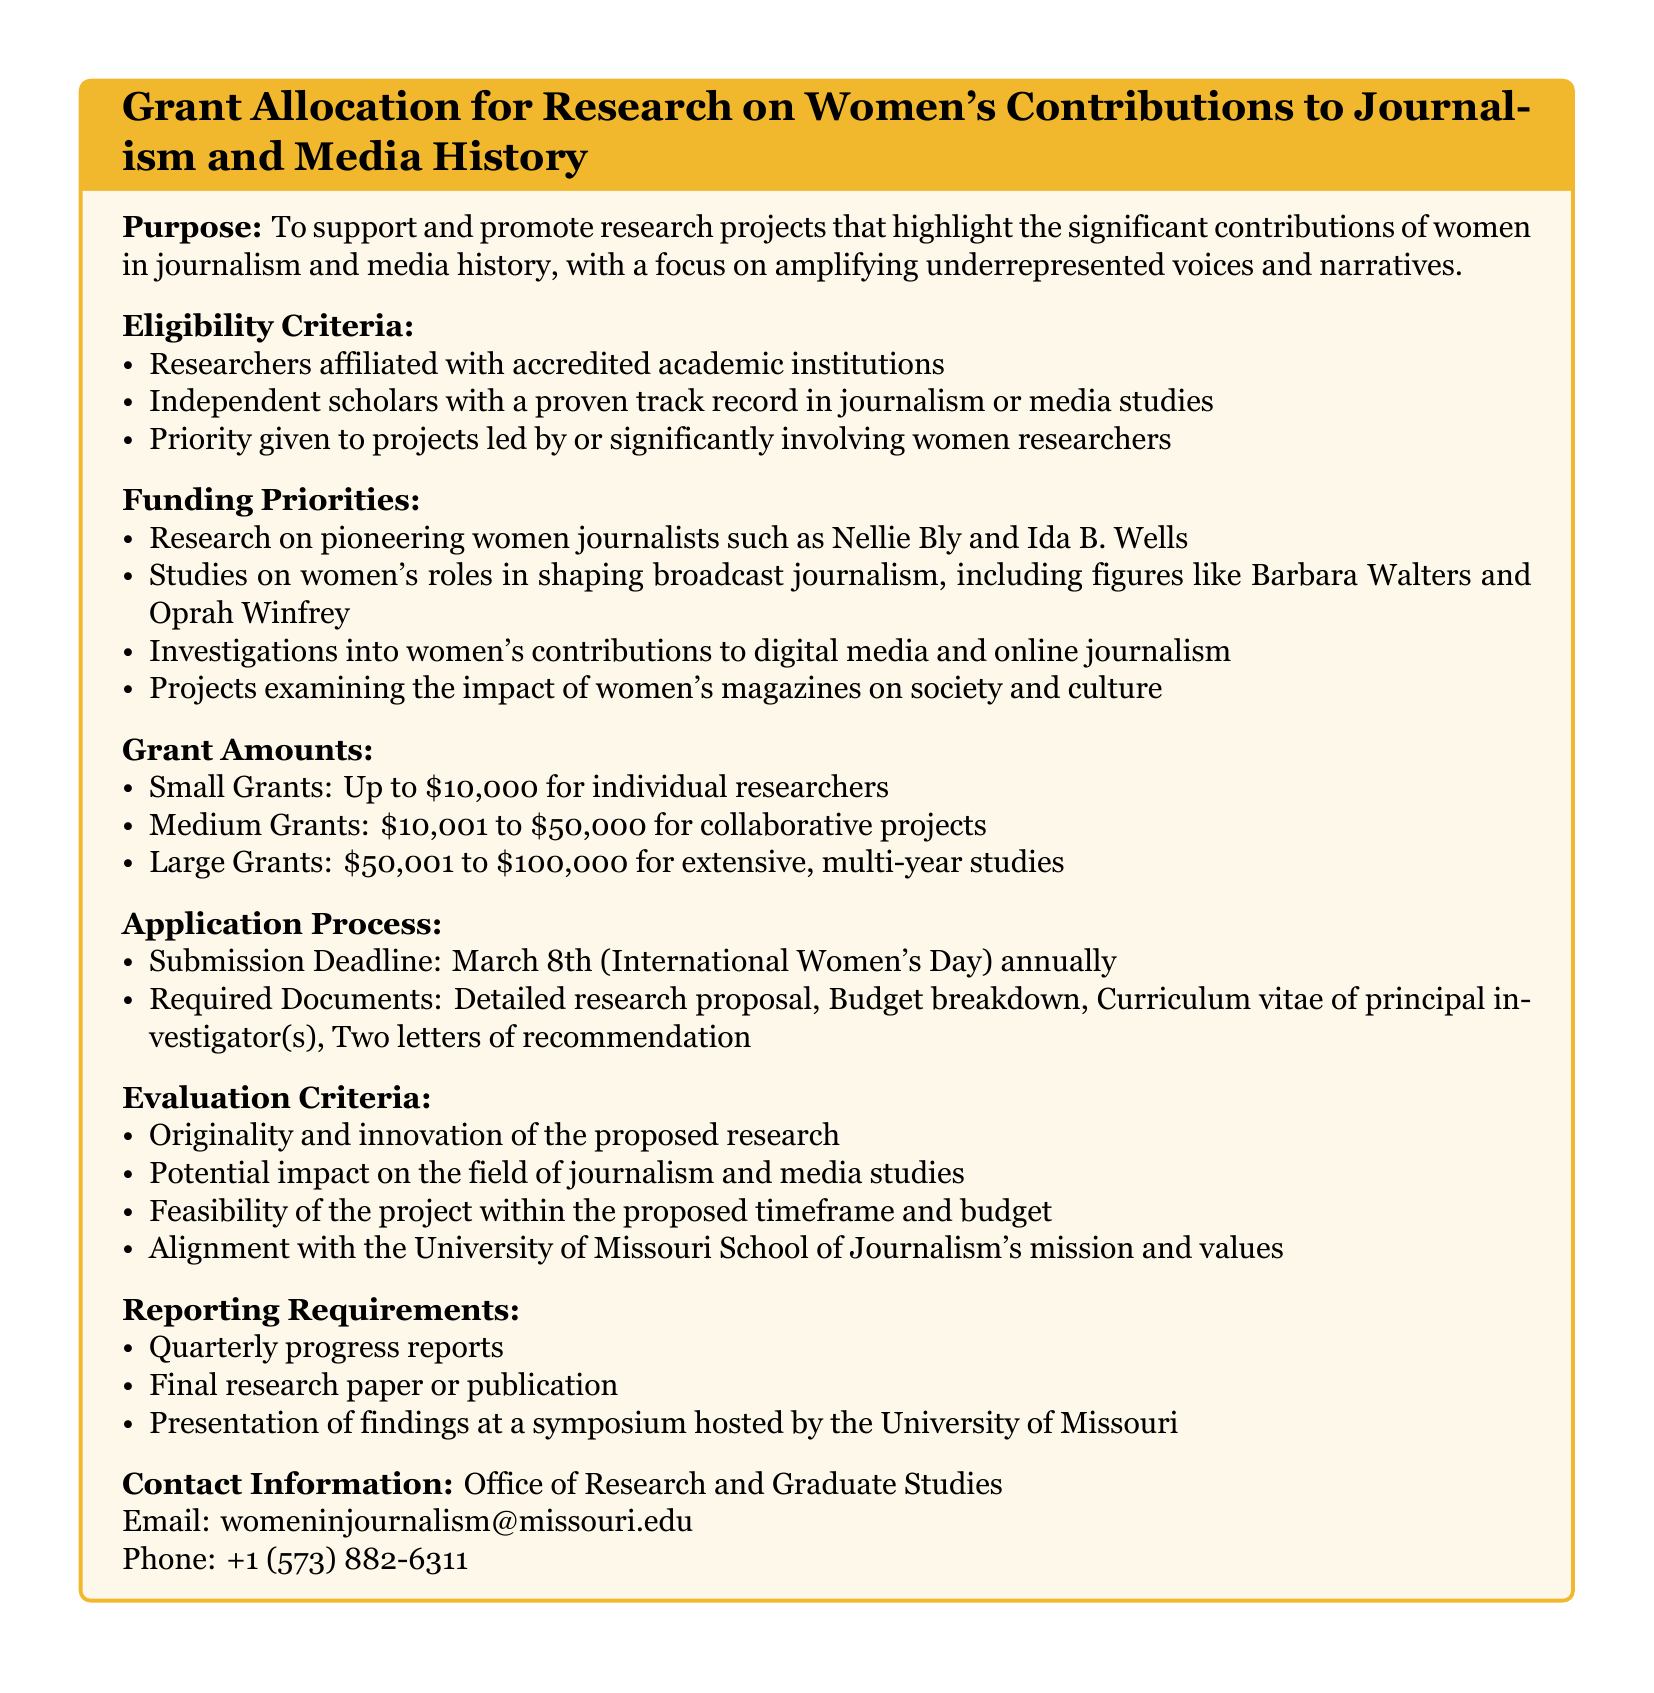What is the purpose of the grant allocation? The purpose is to support and promote research projects that highlight the significant contributions of women in journalism and media history.
Answer: To support and promote research projects that highlight the significant contributions of women in journalism and media history Who is eligible to apply for the grants? The eligibility criteria list researchers affiliated with accredited academic institutions, independent scholars, and projects led by or significantly involving women researchers.
Answer: Researchers affiliated with accredited academic institutions, independent scholars with a proven track record in journalism or media studies, Priority given to projects led by or significantly involving women researchers What is the small grant amount? The document specifies various grant amounts, and the small grant is defined as up to ten thousand dollars.
Answer: Up to $10,000 What is the submission deadline for applications? The document states the submission deadline is March 8th, which coincides with International Women's Day.
Answer: March 8th What type of studies are prioritized for funding? The funding priorities include research on pioneering women journalists, studies on women's roles in broadcast journalism, investigations into digital media contributions, and projects on women's magazines.
Answer: Research on pioneering women journalists such as Nellie Bly and Ida B. Wells, Studies on women's roles in shaping broadcast journalism, Investigations into women's contributions to digital media and online journalism, Projects examining the impact of women's magazines on society and culture What are the reporting requirements after receiving a grant? The reporting requirements include quarterly progress reports, a final research paper or publication, and a presentation of findings.
Answer: Quarterly progress reports, Final research paper or publication, Presentation of findings at a symposium hosted by the University of Missouri How will the applications be evaluated? Evaluation criteria include originality and innovation, potential impact, feasibility, and alignment with the University of Missouri School of Journalism's mission.
Answer: Originality and innovation of the proposed research, Potential impact on the field of journalism and media studies, Feasibility of the project within the proposed timeframe and budget, Alignment with the University of Missouri School of Journalism's mission and values 